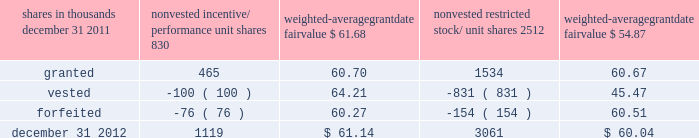To determine stock-based compensation expense , the grant- date fair value is applied to the options granted with a reduction for estimated forfeitures .
We recognize compensation expense for stock options on a straight-line basis over the pro rata vesting period .
At december 31 , 2011 and 2010 , options for 12337000 and 13397000 shares of common stock were exercisable at a weighted-average price of $ 106.08 and $ 118.21 , respectively .
The total intrinsic value of options exercised during 2012 , 2011 and 2010 was $ 37 million , $ 4 million and $ 5 million .
Cash received from option exercises under all incentive plans for 2012 , 2011 and 2010 was approximately $ 118 million , $ 41 million and $ 15 million , respectively .
The actual tax benefit realized for tax deduction purposes from option exercises under all incentive plans for 2012 , 2011 and 2010 was approximately $ 41 million , $ 14 million and $ 5 million , respectively .
There were no options granted in excess of market value in 2012 , 2011 or 2010 .
Shares of common stock available during the next year for the granting of options and other awards under the incentive plans were 29192854 at december 31 , 2012 .
Total shares of pnc common stock authorized for future issuance under equity compensation plans totaled 30537674 shares at december 31 , 2012 , which includes shares available for issuance under the incentive plans and the employee stock purchase plan ( espp ) as described below .
During 2012 , we issued approximately 1.7 million shares from treasury stock in connection with stock option exercise activity .
As with past exercise activity , we currently intend to utilize primarily treasury stock for any future stock option exercises .
Awards granted to non-employee directors in 2012 , 2011 and 2010 include 25620 , 27090 and 29040 deferred stock units , respectively , awarded under the outside directors deferred stock unit plan .
A deferred stock unit is a phantom share of our common stock , which requires liability accounting treatment until such awards are paid to the participants as cash .
As there are no vesting or service requirements on these awards , total compensation expense is recognized in full on awarded deferred stock units on the date of grant .
Incentive/performance unit share awards and restricted stock/unit awards the fair value of nonvested incentive/performance unit share awards and restricted stock/unit awards is initially determined based on prices not less than the market value of our common stock price on the date of grant .
The value of certain incentive/ performance unit share awards is subsequently remeasured based on the achievement of one or more financial and other performance goals generally over a three-year period .
The personnel and compensation committee of the board of directors approves the final award payout with respect to incentive/performance unit share awards .
Restricted stock/unit awards have various vesting periods generally ranging from 36 months to 60 months .
Beginning in 2012 , we incorporated several risk-related performance changes to certain incentive compensation programs .
In addition to achieving certain financial performance metrics relative to our peers , the final payout amount will be subject to a negative adjustment if pnc fails to meet certain risk-related performance metrics as specified in the award agreement .
However , the p&cc has the discretion to reduce any or all of this negative adjustment under certain circumstances .
These awards have a three-year performance period and are payable in either stock or a combination of stock and cash .
Additionally , performance-based restricted share units were granted in 2012 to certain of our executives in lieu of stock options , with generally the same terms and conditions as the 2011 awards of the same .
The weighted-average grant-date fair value of incentive/ performance unit share awards and restricted stock/unit awards granted in 2012 , 2011 and 2010 was $ 60.68 , $ 63.25 and $ 54.59 per share , respectively .
We recognize compensation expense for such awards ratably over the corresponding vesting and/or performance periods for each type of program .
Table 130 : nonvested incentive/performance unit share awards and restricted stock/unit awards 2013 rollforward shares in thousands nonvested incentive/ performance unit shares weighted- average date fair nonvested restricted stock/ shares weighted- average date fair .
In the chart above , the unit shares and related weighted- average grant-date fair value of the incentive/performance awards exclude the effect of dividends on the underlying shares , as those dividends will be paid in cash .
At december 31 , 2012 , there was $ 86 million of unrecognized deferred compensation expense related to nonvested share- based compensation arrangements granted under the incentive plans .
This cost is expected to be recognized as expense over a period of no longer than five years .
The total fair value of incentive/performance unit share and restricted stock/unit awards vested during 2012 , 2011 and 2010 was approximately $ 55 million , $ 52 million and $ 39 million , respectively .
The pnc financial services group , inc .
2013 form 10-k 203 .
What was the average cost per unit for the weighted-average grant-date fair value of incentive/ performance unit share awards and restricted stock/unit awards granted in 2012 , 2011 and 2010? 
Computations: (((60.68 + 63.25) + 54.59) / 3)
Answer: 59.50667. 